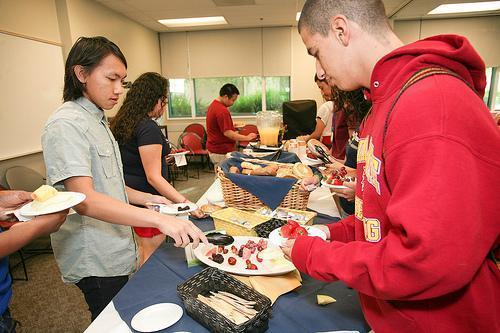How many people in red are getting orange juice?
Give a very brief answer. 1. 